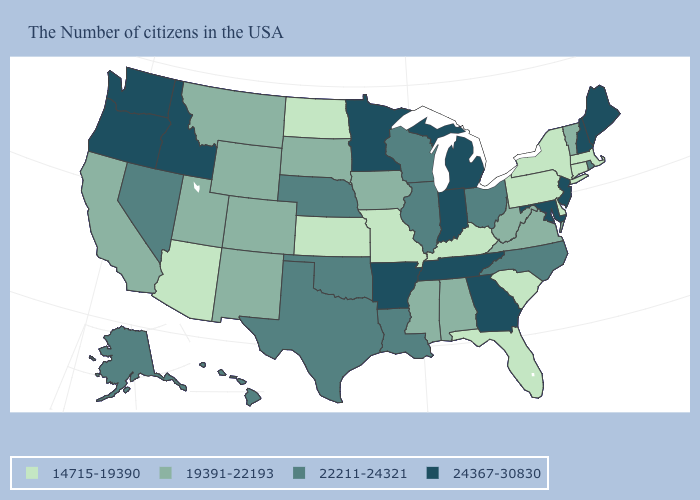What is the value of California?
Keep it brief. 19391-22193. What is the value of Colorado?
Short answer required. 19391-22193. Which states have the lowest value in the USA?
Be succinct. Massachusetts, Connecticut, New York, Delaware, Pennsylvania, South Carolina, Florida, Kentucky, Missouri, Kansas, North Dakota, Arizona. Name the states that have a value in the range 19391-22193?
Be succinct. Vermont, Virginia, West Virginia, Alabama, Mississippi, Iowa, South Dakota, Wyoming, Colorado, New Mexico, Utah, Montana, California. What is the value of Oregon?
Keep it brief. 24367-30830. How many symbols are there in the legend?
Give a very brief answer. 4. Name the states that have a value in the range 24367-30830?
Keep it brief. Maine, New Hampshire, New Jersey, Maryland, Georgia, Michigan, Indiana, Tennessee, Arkansas, Minnesota, Idaho, Washington, Oregon. How many symbols are there in the legend?
Keep it brief. 4. Name the states that have a value in the range 22211-24321?
Give a very brief answer. Rhode Island, North Carolina, Ohio, Wisconsin, Illinois, Louisiana, Nebraska, Oklahoma, Texas, Nevada, Alaska, Hawaii. Does Alaska have the same value as Wisconsin?
Keep it brief. Yes. How many symbols are there in the legend?
Give a very brief answer. 4. What is the value of Oregon?
Give a very brief answer. 24367-30830. What is the value of Nevada?
Be succinct. 22211-24321. Does Nevada have the lowest value in the USA?
Give a very brief answer. No. What is the value of California?
Give a very brief answer. 19391-22193. 